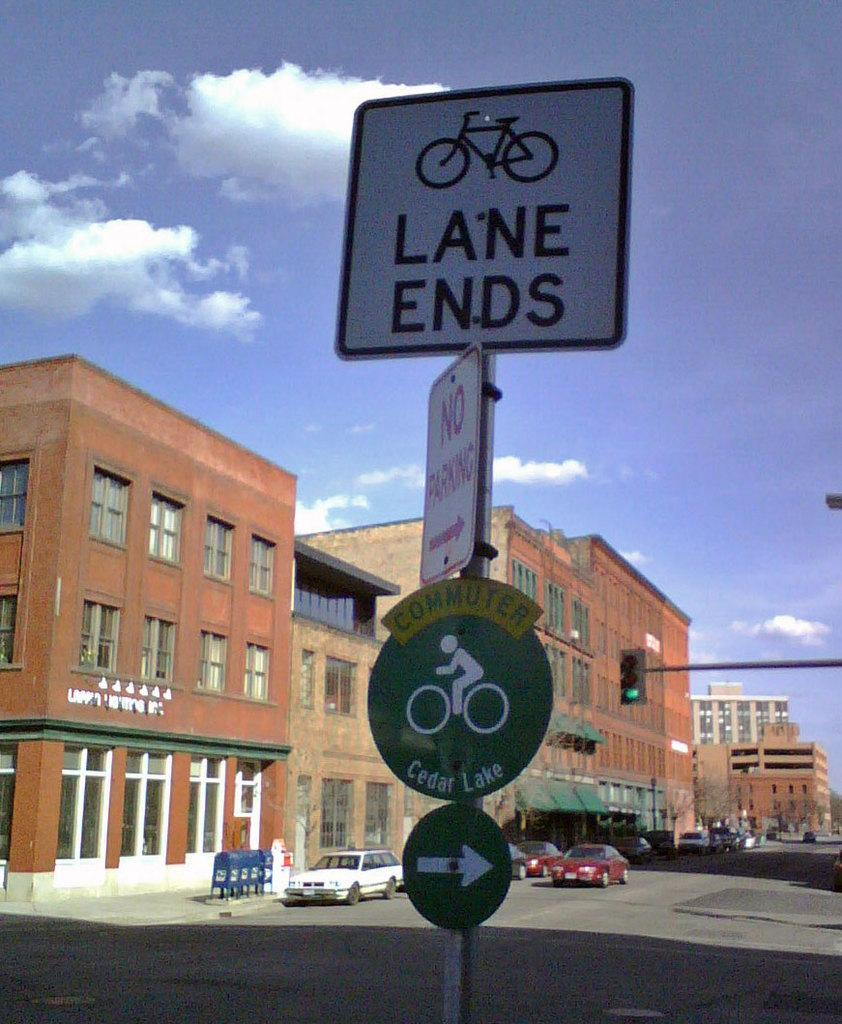Provide a one-sentence caption for the provided image. The bicycle lane ends but there is another one to the right that goes to Cedar Lake. 